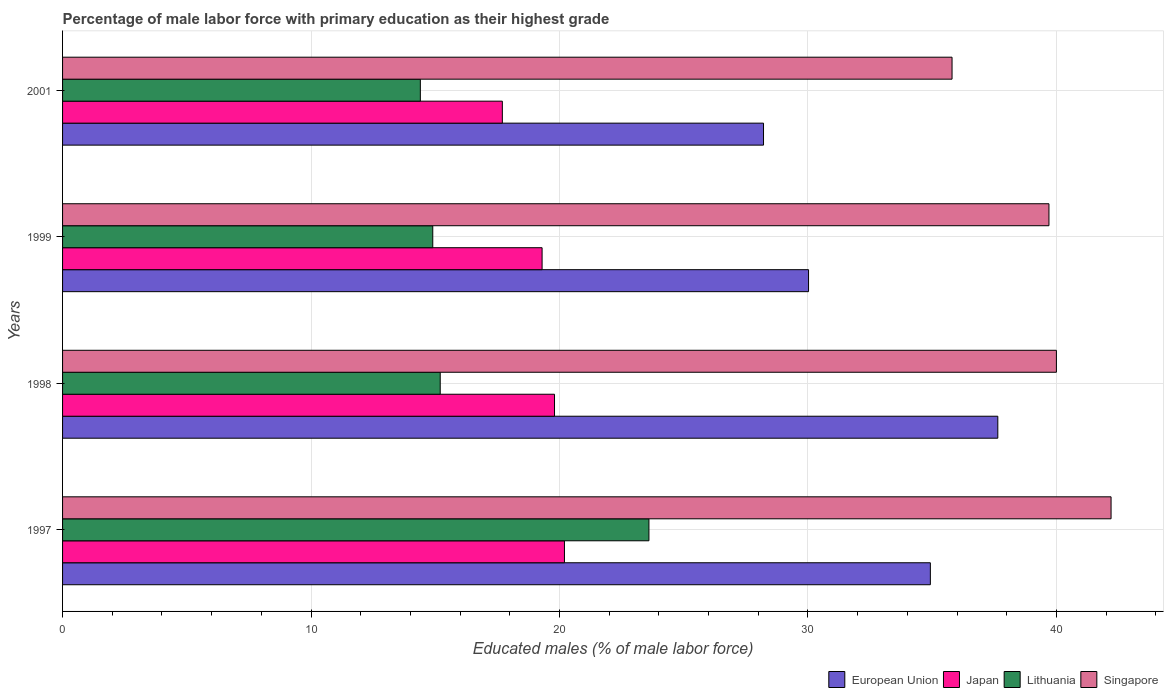How many different coloured bars are there?
Your answer should be very brief. 4. How many groups of bars are there?
Offer a very short reply. 4. Are the number of bars on each tick of the Y-axis equal?
Your response must be concise. Yes. How many bars are there on the 2nd tick from the top?
Offer a very short reply. 4. How many bars are there on the 2nd tick from the bottom?
Ensure brevity in your answer.  4. What is the label of the 3rd group of bars from the top?
Your answer should be very brief. 1998. In how many cases, is the number of bars for a given year not equal to the number of legend labels?
Your answer should be compact. 0. What is the percentage of male labor force with primary education in Japan in 2001?
Provide a short and direct response. 17.7. Across all years, what is the maximum percentage of male labor force with primary education in European Union?
Give a very brief answer. 37.64. Across all years, what is the minimum percentage of male labor force with primary education in Singapore?
Provide a succinct answer. 35.8. In which year was the percentage of male labor force with primary education in European Union maximum?
Your answer should be very brief. 1998. What is the total percentage of male labor force with primary education in European Union in the graph?
Your answer should be compact. 130.8. What is the difference between the percentage of male labor force with primary education in European Union in 1998 and that in 2001?
Offer a very short reply. 9.43. What is the difference between the percentage of male labor force with primary education in European Union in 1998 and the percentage of male labor force with primary education in Japan in 1999?
Keep it short and to the point. 18.34. What is the average percentage of male labor force with primary education in European Union per year?
Your answer should be compact. 32.7. In the year 1998, what is the difference between the percentage of male labor force with primary education in Japan and percentage of male labor force with primary education in Lithuania?
Keep it short and to the point. 4.6. What is the ratio of the percentage of male labor force with primary education in European Union in 1997 to that in 2001?
Your answer should be compact. 1.24. What is the difference between the highest and the second highest percentage of male labor force with primary education in Japan?
Your answer should be compact. 0.4. What is the difference between the highest and the lowest percentage of male labor force with primary education in European Union?
Keep it short and to the point. 9.43. In how many years, is the percentage of male labor force with primary education in Lithuania greater than the average percentage of male labor force with primary education in Lithuania taken over all years?
Your answer should be compact. 1. Is it the case that in every year, the sum of the percentage of male labor force with primary education in Japan and percentage of male labor force with primary education in Lithuania is greater than the sum of percentage of male labor force with primary education in European Union and percentage of male labor force with primary education in Singapore?
Your answer should be very brief. No. What does the 4th bar from the bottom in 1998 represents?
Provide a succinct answer. Singapore. How many bars are there?
Keep it short and to the point. 16. Are all the bars in the graph horizontal?
Your answer should be compact. Yes. How many years are there in the graph?
Keep it short and to the point. 4. Does the graph contain any zero values?
Ensure brevity in your answer.  No. How are the legend labels stacked?
Provide a succinct answer. Horizontal. What is the title of the graph?
Give a very brief answer. Percentage of male labor force with primary education as their highest grade. What is the label or title of the X-axis?
Your answer should be very brief. Educated males (% of male labor force). What is the Educated males (% of male labor force) of European Union in 1997?
Your response must be concise. 34.93. What is the Educated males (% of male labor force) of Japan in 1997?
Ensure brevity in your answer.  20.2. What is the Educated males (% of male labor force) in Lithuania in 1997?
Provide a short and direct response. 23.6. What is the Educated males (% of male labor force) of Singapore in 1997?
Your response must be concise. 42.2. What is the Educated males (% of male labor force) of European Union in 1998?
Give a very brief answer. 37.64. What is the Educated males (% of male labor force) in Japan in 1998?
Your response must be concise. 19.8. What is the Educated males (% of male labor force) of Lithuania in 1998?
Your answer should be very brief. 15.2. What is the Educated males (% of male labor force) of European Union in 1999?
Your response must be concise. 30.02. What is the Educated males (% of male labor force) of Japan in 1999?
Offer a very short reply. 19.3. What is the Educated males (% of male labor force) of Lithuania in 1999?
Offer a very short reply. 14.9. What is the Educated males (% of male labor force) in Singapore in 1999?
Offer a very short reply. 39.7. What is the Educated males (% of male labor force) in European Union in 2001?
Keep it short and to the point. 28.21. What is the Educated males (% of male labor force) in Japan in 2001?
Provide a short and direct response. 17.7. What is the Educated males (% of male labor force) of Lithuania in 2001?
Provide a succinct answer. 14.4. What is the Educated males (% of male labor force) of Singapore in 2001?
Give a very brief answer. 35.8. Across all years, what is the maximum Educated males (% of male labor force) in European Union?
Keep it short and to the point. 37.64. Across all years, what is the maximum Educated males (% of male labor force) in Japan?
Keep it short and to the point. 20.2. Across all years, what is the maximum Educated males (% of male labor force) of Lithuania?
Provide a succinct answer. 23.6. Across all years, what is the maximum Educated males (% of male labor force) of Singapore?
Ensure brevity in your answer.  42.2. Across all years, what is the minimum Educated males (% of male labor force) in European Union?
Your answer should be very brief. 28.21. Across all years, what is the minimum Educated males (% of male labor force) in Japan?
Ensure brevity in your answer.  17.7. Across all years, what is the minimum Educated males (% of male labor force) in Lithuania?
Provide a succinct answer. 14.4. Across all years, what is the minimum Educated males (% of male labor force) in Singapore?
Offer a terse response. 35.8. What is the total Educated males (% of male labor force) in European Union in the graph?
Ensure brevity in your answer.  130.8. What is the total Educated males (% of male labor force) of Japan in the graph?
Provide a short and direct response. 77. What is the total Educated males (% of male labor force) in Lithuania in the graph?
Make the answer very short. 68.1. What is the total Educated males (% of male labor force) of Singapore in the graph?
Your response must be concise. 157.7. What is the difference between the Educated males (% of male labor force) in European Union in 1997 and that in 1998?
Your answer should be compact. -2.71. What is the difference between the Educated males (% of male labor force) in European Union in 1997 and that in 1999?
Provide a short and direct response. 4.9. What is the difference between the Educated males (% of male labor force) of Singapore in 1997 and that in 1999?
Keep it short and to the point. 2.5. What is the difference between the Educated males (% of male labor force) in European Union in 1997 and that in 2001?
Provide a short and direct response. 6.71. What is the difference between the Educated males (% of male labor force) of European Union in 1998 and that in 1999?
Keep it short and to the point. 7.62. What is the difference between the Educated males (% of male labor force) of Japan in 1998 and that in 1999?
Ensure brevity in your answer.  0.5. What is the difference between the Educated males (% of male labor force) in Singapore in 1998 and that in 1999?
Ensure brevity in your answer.  0.3. What is the difference between the Educated males (% of male labor force) of European Union in 1998 and that in 2001?
Offer a very short reply. 9.43. What is the difference between the Educated males (% of male labor force) in Lithuania in 1998 and that in 2001?
Your answer should be very brief. 0.8. What is the difference between the Educated males (% of male labor force) in Singapore in 1998 and that in 2001?
Offer a very short reply. 4.2. What is the difference between the Educated males (% of male labor force) of European Union in 1999 and that in 2001?
Provide a short and direct response. 1.81. What is the difference between the Educated males (% of male labor force) in European Union in 1997 and the Educated males (% of male labor force) in Japan in 1998?
Give a very brief answer. 15.13. What is the difference between the Educated males (% of male labor force) of European Union in 1997 and the Educated males (% of male labor force) of Lithuania in 1998?
Ensure brevity in your answer.  19.73. What is the difference between the Educated males (% of male labor force) of European Union in 1997 and the Educated males (% of male labor force) of Singapore in 1998?
Your answer should be very brief. -5.07. What is the difference between the Educated males (% of male labor force) of Japan in 1997 and the Educated males (% of male labor force) of Lithuania in 1998?
Ensure brevity in your answer.  5. What is the difference between the Educated males (% of male labor force) of Japan in 1997 and the Educated males (% of male labor force) of Singapore in 1998?
Make the answer very short. -19.8. What is the difference between the Educated males (% of male labor force) in Lithuania in 1997 and the Educated males (% of male labor force) in Singapore in 1998?
Keep it short and to the point. -16.4. What is the difference between the Educated males (% of male labor force) of European Union in 1997 and the Educated males (% of male labor force) of Japan in 1999?
Offer a very short reply. 15.63. What is the difference between the Educated males (% of male labor force) of European Union in 1997 and the Educated males (% of male labor force) of Lithuania in 1999?
Keep it short and to the point. 20.03. What is the difference between the Educated males (% of male labor force) in European Union in 1997 and the Educated males (% of male labor force) in Singapore in 1999?
Your answer should be very brief. -4.77. What is the difference between the Educated males (% of male labor force) of Japan in 1997 and the Educated males (% of male labor force) of Lithuania in 1999?
Your answer should be very brief. 5.3. What is the difference between the Educated males (% of male labor force) of Japan in 1997 and the Educated males (% of male labor force) of Singapore in 1999?
Your response must be concise. -19.5. What is the difference between the Educated males (% of male labor force) of Lithuania in 1997 and the Educated males (% of male labor force) of Singapore in 1999?
Ensure brevity in your answer.  -16.1. What is the difference between the Educated males (% of male labor force) of European Union in 1997 and the Educated males (% of male labor force) of Japan in 2001?
Your answer should be very brief. 17.23. What is the difference between the Educated males (% of male labor force) in European Union in 1997 and the Educated males (% of male labor force) in Lithuania in 2001?
Make the answer very short. 20.53. What is the difference between the Educated males (% of male labor force) in European Union in 1997 and the Educated males (% of male labor force) in Singapore in 2001?
Make the answer very short. -0.87. What is the difference between the Educated males (% of male labor force) in Japan in 1997 and the Educated males (% of male labor force) in Singapore in 2001?
Provide a short and direct response. -15.6. What is the difference between the Educated males (% of male labor force) in Lithuania in 1997 and the Educated males (% of male labor force) in Singapore in 2001?
Keep it short and to the point. -12.2. What is the difference between the Educated males (% of male labor force) of European Union in 1998 and the Educated males (% of male labor force) of Japan in 1999?
Your answer should be compact. 18.34. What is the difference between the Educated males (% of male labor force) of European Union in 1998 and the Educated males (% of male labor force) of Lithuania in 1999?
Provide a succinct answer. 22.74. What is the difference between the Educated males (% of male labor force) of European Union in 1998 and the Educated males (% of male labor force) of Singapore in 1999?
Provide a succinct answer. -2.06. What is the difference between the Educated males (% of male labor force) in Japan in 1998 and the Educated males (% of male labor force) in Lithuania in 1999?
Your response must be concise. 4.9. What is the difference between the Educated males (% of male labor force) of Japan in 1998 and the Educated males (% of male labor force) of Singapore in 1999?
Provide a succinct answer. -19.9. What is the difference between the Educated males (% of male labor force) of Lithuania in 1998 and the Educated males (% of male labor force) of Singapore in 1999?
Provide a short and direct response. -24.5. What is the difference between the Educated males (% of male labor force) of European Union in 1998 and the Educated males (% of male labor force) of Japan in 2001?
Your response must be concise. 19.94. What is the difference between the Educated males (% of male labor force) of European Union in 1998 and the Educated males (% of male labor force) of Lithuania in 2001?
Offer a terse response. 23.24. What is the difference between the Educated males (% of male labor force) of European Union in 1998 and the Educated males (% of male labor force) of Singapore in 2001?
Keep it short and to the point. 1.84. What is the difference between the Educated males (% of male labor force) in Lithuania in 1998 and the Educated males (% of male labor force) in Singapore in 2001?
Keep it short and to the point. -20.6. What is the difference between the Educated males (% of male labor force) of European Union in 1999 and the Educated males (% of male labor force) of Japan in 2001?
Provide a short and direct response. 12.32. What is the difference between the Educated males (% of male labor force) in European Union in 1999 and the Educated males (% of male labor force) in Lithuania in 2001?
Provide a short and direct response. 15.62. What is the difference between the Educated males (% of male labor force) of European Union in 1999 and the Educated males (% of male labor force) of Singapore in 2001?
Give a very brief answer. -5.78. What is the difference between the Educated males (% of male labor force) of Japan in 1999 and the Educated males (% of male labor force) of Lithuania in 2001?
Give a very brief answer. 4.9. What is the difference between the Educated males (% of male labor force) of Japan in 1999 and the Educated males (% of male labor force) of Singapore in 2001?
Offer a very short reply. -16.5. What is the difference between the Educated males (% of male labor force) in Lithuania in 1999 and the Educated males (% of male labor force) in Singapore in 2001?
Keep it short and to the point. -20.9. What is the average Educated males (% of male labor force) in European Union per year?
Provide a short and direct response. 32.7. What is the average Educated males (% of male labor force) of Japan per year?
Ensure brevity in your answer.  19.25. What is the average Educated males (% of male labor force) in Lithuania per year?
Make the answer very short. 17.02. What is the average Educated males (% of male labor force) in Singapore per year?
Offer a terse response. 39.42. In the year 1997, what is the difference between the Educated males (% of male labor force) of European Union and Educated males (% of male labor force) of Japan?
Offer a terse response. 14.73. In the year 1997, what is the difference between the Educated males (% of male labor force) in European Union and Educated males (% of male labor force) in Lithuania?
Your answer should be very brief. 11.33. In the year 1997, what is the difference between the Educated males (% of male labor force) in European Union and Educated males (% of male labor force) in Singapore?
Your answer should be compact. -7.27. In the year 1997, what is the difference between the Educated males (% of male labor force) in Japan and Educated males (% of male labor force) in Lithuania?
Offer a terse response. -3.4. In the year 1997, what is the difference between the Educated males (% of male labor force) in Japan and Educated males (% of male labor force) in Singapore?
Your response must be concise. -22. In the year 1997, what is the difference between the Educated males (% of male labor force) of Lithuania and Educated males (% of male labor force) of Singapore?
Your answer should be compact. -18.6. In the year 1998, what is the difference between the Educated males (% of male labor force) of European Union and Educated males (% of male labor force) of Japan?
Keep it short and to the point. 17.84. In the year 1998, what is the difference between the Educated males (% of male labor force) in European Union and Educated males (% of male labor force) in Lithuania?
Provide a short and direct response. 22.44. In the year 1998, what is the difference between the Educated males (% of male labor force) in European Union and Educated males (% of male labor force) in Singapore?
Ensure brevity in your answer.  -2.36. In the year 1998, what is the difference between the Educated males (% of male labor force) in Japan and Educated males (% of male labor force) in Lithuania?
Your response must be concise. 4.6. In the year 1998, what is the difference between the Educated males (% of male labor force) in Japan and Educated males (% of male labor force) in Singapore?
Make the answer very short. -20.2. In the year 1998, what is the difference between the Educated males (% of male labor force) in Lithuania and Educated males (% of male labor force) in Singapore?
Ensure brevity in your answer.  -24.8. In the year 1999, what is the difference between the Educated males (% of male labor force) in European Union and Educated males (% of male labor force) in Japan?
Ensure brevity in your answer.  10.72. In the year 1999, what is the difference between the Educated males (% of male labor force) of European Union and Educated males (% of male labor force) of Lithuania?
Your response must be concise. 15.12. In the year 1999, what is the difference between the Educated males (% of male labor force) in European Union and Educated males (% of male labor force) in Singapore?
Provide a succinct answer. -9.68. In the year 1999, what is the difference between the Educated males (% of male labor force) of Japan and Educated males (% of male labor force) of Singapore?
Your answer should be very brief. -20.4. In the year 1999, what is the difference between the Educated males (% of male labor force) in Lithuania and Educated males (% of male labor force) in Singapore?
Your answer should be very brief. -24.8. In the year 2001, what is the difference between the Educated males (% of male labor force) of European Union and Educated males (% of male labor force) of Japan?
Your answer should be very brief. 10.51. In the year 2001, what is the difference between the Educated males (% of male labor force) in European Union and Educated males (% of male labor force) in Lithuania?
Ensure brevity in your answer.  13.81. In the year 2001, what is the difference between the Educated males (% of male labor force) in European Union and Educated males (% of male labor force) in Singapore?
Ensure brevity in your answer.  -7.59. In the year 2001, what is the difference between the Educated males (% of male labor force) of Japan and Educated males (% of male labor force) of Lithuania?
Your response must be concise. 3.3. In the year 2001, what is the difference between the Educated males (% of male labor force) in Japan and Educated males (% of male labor force) in Singapore?
Give a very brief answer. -18.1. In the year 2001, what is the difference between the Educated males (% of male labor force) of Lithuania and Educated males (% of male labor force) of Singapore?
Offer a very short reply. -21.4. What is the ratio of the Educated males (% of male labor force) in European Union in 1997 to that in 1998?
Give a very brief answer. 0.93. What is the ratio of the Educated males (% of male labor force) in Japan in 1997 to that in 1998?
Offer a very short reply. 1.02. What is the ratio of the Educated males (% of male labor force) in Lithuania in 1997 to that in 1998?
Ensure brevity in your answer.  1.55. What is the ratio of the Educated males (% of male labor force) of Singapore in 1997 to that in 1998?
Provide a short and direct response. 1.05. What is the ratio of the Educated males (% of male labor force) in European Union in 1997 to that in 1999?
Your response must be concise. 1.16. What is the ratio of the Educated males (% of male labor force) of Japan in 1997 to that in 1999?
Offer a very short reply. 1.05. What is the ratio of the Educated males (% of male labor force) of Lithuania in 1997 to that in 1999?
Your answer should be compact. 1.58. What is the ratio of the Educated males (% of male labor force) in Singapore in 1997 to that in 1999?
Give a very brief answer. 1.06. What is the ratio of the Educated males (% of male labor force) of European Union in 1997 to that in 2001?
Provide a succinct answer. 1.24. What is the ratio of the Educated males (% of male labor force) of Japan in 1997 to that in 2001?
Offer a very short reply. 1.14. What is the ratio of the Educated males (% of male labor force) in Lithuania in 1997 to that in 2001?
Your answer should be compact. 1.64. What is the ratio of the Educated males (% of male labor force) in Singapore in 1997 to that in 2001?
Your answer should be very brief. 1.18. What is the ratio of the Educated males (% of male labor force) in European Union in 1998 to that in 1999?
Ensure brevity in your answer.  1.25. What is the ratio of the Educated males (% of male labor force) in Japan in 1998 to that in 1999?
Offer a very short reply. 1.03. What is the ratio of the Educated males (% of male labor force) of Lithuania in 1998 to that in 1999?
Make the answer very short. 1.02. What is the ratio of the Educated males (% of male labor force) of Singapore in 1998 to that in 1999?
Offer a terse response. 1.01. What is the ratio of the Educated males (% of male labor force) of European Union in 1998 to that in 2001?
Offer a very short reply. 1.33. What is the ratio of the Educated males (% of male labor force) of Japan in 1998 to that in 2001?
Your answer should be very brief. 1.12. What is the ratio of the Educated males (% of male labor force) of Lithuania in 1998 to that in 2001?
Offer a terse response. 1.06. What is the ratio of the Educated males (% of male labor force) in Singapore in 1998 to that in 2001?
Provide a short and direct response. 1.12. What is the ratio of the Educated males (% of male labor force) of European Union in 1999 to that in 2001?
Offer a terse response. 1.06. What is the ratio of the Educated males (% of male labor force) of Japan in 1999 to that in 2001?
Your answer should be very brief. 1.09. What is the ratio of the Educated males (% of male labor force) of Lithuania in 1999 to that in 2001?
Make the answer very short. 1.03. What is the ratio of the Educated males (% of male labor force) of Singapore in 1999 to that in 2001?
Keep it short and to the point. 1.11. What is the difference between the highest and the second highest Educated males (% of male labor force) of European Union?
Ensure brevity in your answer.  2.71. What is the difference between the highest and the lowest Educated males (% of male labor force) in European Union?
Your response must be concise. 9.43. What is the difference between the highest and the lowest Educated males (% of male labor force) in Singapore?
Make the answer very short. 6.4. 